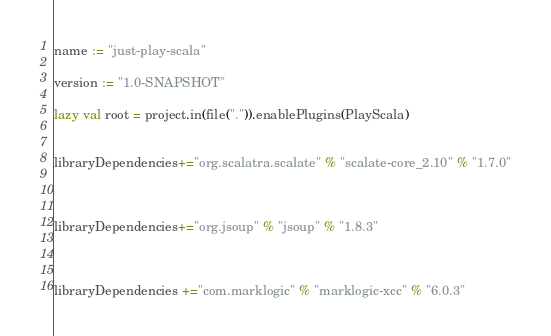Convert code to text. <code><loc_0><loc_0><loc_500><loc_500><_Scala_>name := "just-play-scala"

version := "1.0-SNAPSHOT"

lazy val root = project.in(file(".")).enablePlugins(PlayScala)


libraryDependencies+="org.scalatra.scalate" % "scalate-core_2.10" % "1.7.0"



libraryDependencies+="org.jsoup" % "jsoup" % "1.8.3"



libraryDependencies +="com.marklogic" % "marklogic-xcc" % "6.0.3"</code> 